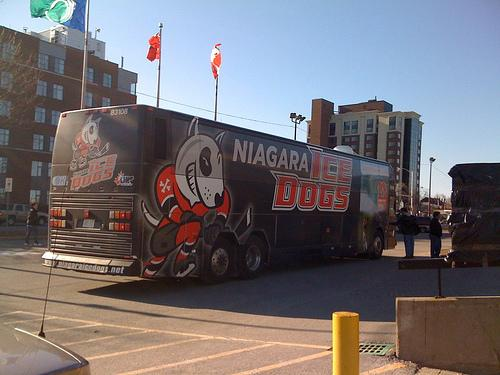What sport is the cartoon dog playing? Please explain your reasoning. ice hockey. The team is niagara ice dogs. 